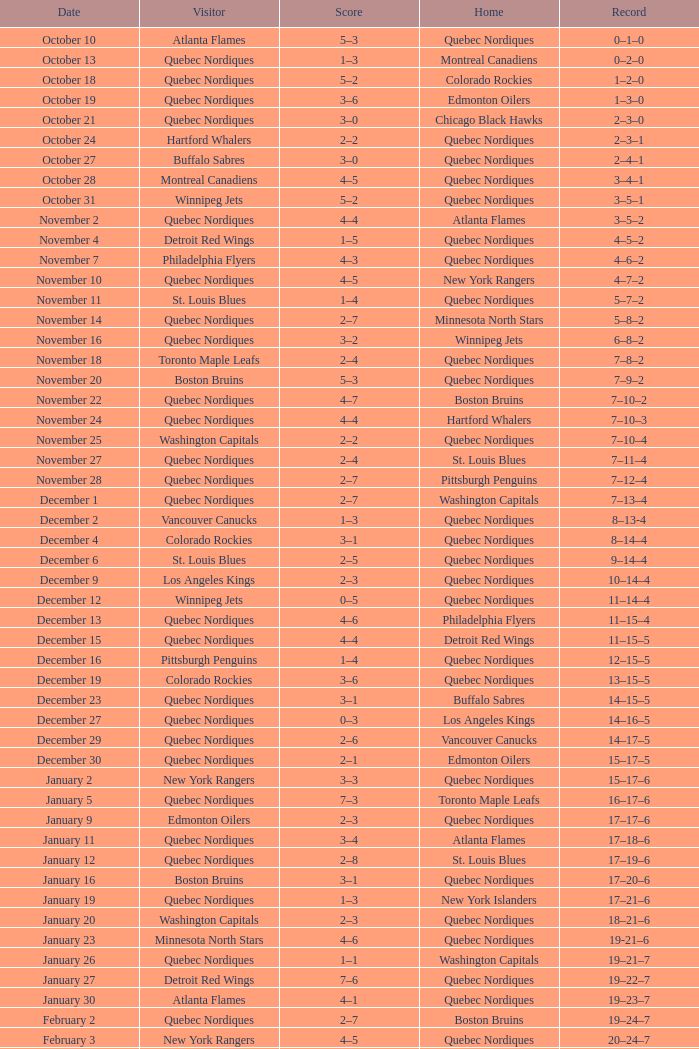Which Date has a Score of 2–7, and a Record of 5–8–2? November 14. 